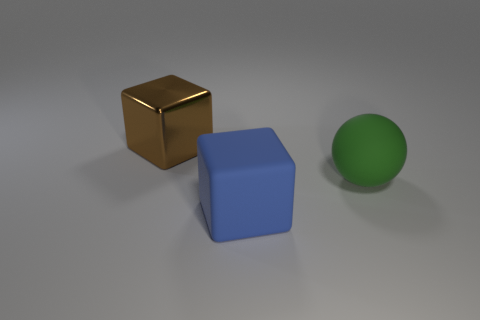Add 3 matte objects. How many objects exist? 6 Subtract all cubes. How many objects are left? 1 Subtract all brown cubes. How many cubes are left? 1 Subtract 0 red cylinders. How many objects are left? 3 Subtract 1 blocks. How many blocks are left? 1 Subtract all gray spheres. Subtract all blue cylinders. How many spheres are left? 1 Subtract all green balls. How many green cubes are left? 0 Subtract all tiny green matte balls. Subtract all blocks. How many objects are left? 1 Add 2 brown blocks. How many brown blocks are left? 3 Add 1 small cyan shiny balls. How many small cyan shiny balls exist? 1 